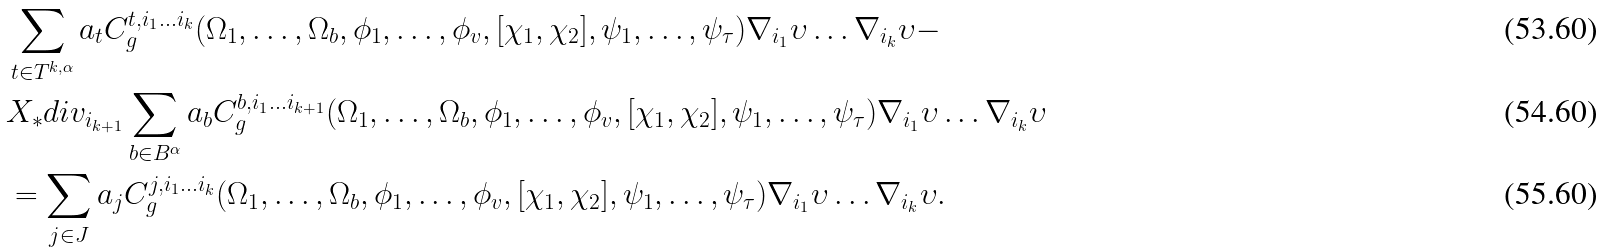Convert formula to latex. <formula><loc_0><loc_0><loc_500><loc_500>& \sum _ { t \in T ^ { k , \alpha } } a _ { t } C ^ { t , i _ { 1 } \dots i _ { k } } _ { g } ( \Omega _ { 1 } , \dots , \Omega _ { b } , \phi _ { 1 } , \dots , \phi _ { v } , [ \chi _ { 1 } , \chi _ { 2 } ] , \psi _ { 1 } , \dots , \psi _ { \tau } ) \nabla _ { i _ { 1 } } \upsilon \dots \nabla _ { i _ { k } } \upsilon - \\ & X _ { * } d i v _ { i _ { k + 1 } } \sum _ { b \in B ^ { \alpha } } a _ { b } C ^ { b , i _ { 1 } \dots i _ { k + 1 } } _ { g } ( \Omega _ { 1 } , \dots , \Omega _ { b } , \phi _ { 1 } , \dots , \phi _ { v } , [ \chi _ { 1 } , \chi _ { 2 } ] , \psi _ { 1 } , \dots , \psi _ { \tau } ) \nabla _ { i _ { 1 } } \upsilon \dots \nabla _ { i _ { k } } \upsilon \\ & = \sum _ { j \in J } a _ { j } C ^ { j , i _ { 1 } \dots i _ { k } } _ { g } ( \Omega _ { 1 } , \dots , \Omega _ { b } , \phi _ { 1 } , \dots , \phi _ { v } , [ \chi _ { 1 } , \chi _ { 2 } ] , \psi _ { 1 } , \dots , \psi _ { \tau } ) \nabla _ { i _ { 1 } } \upsilon \dots \nabla _ { i _ { k } } \upsilon .</formula> 